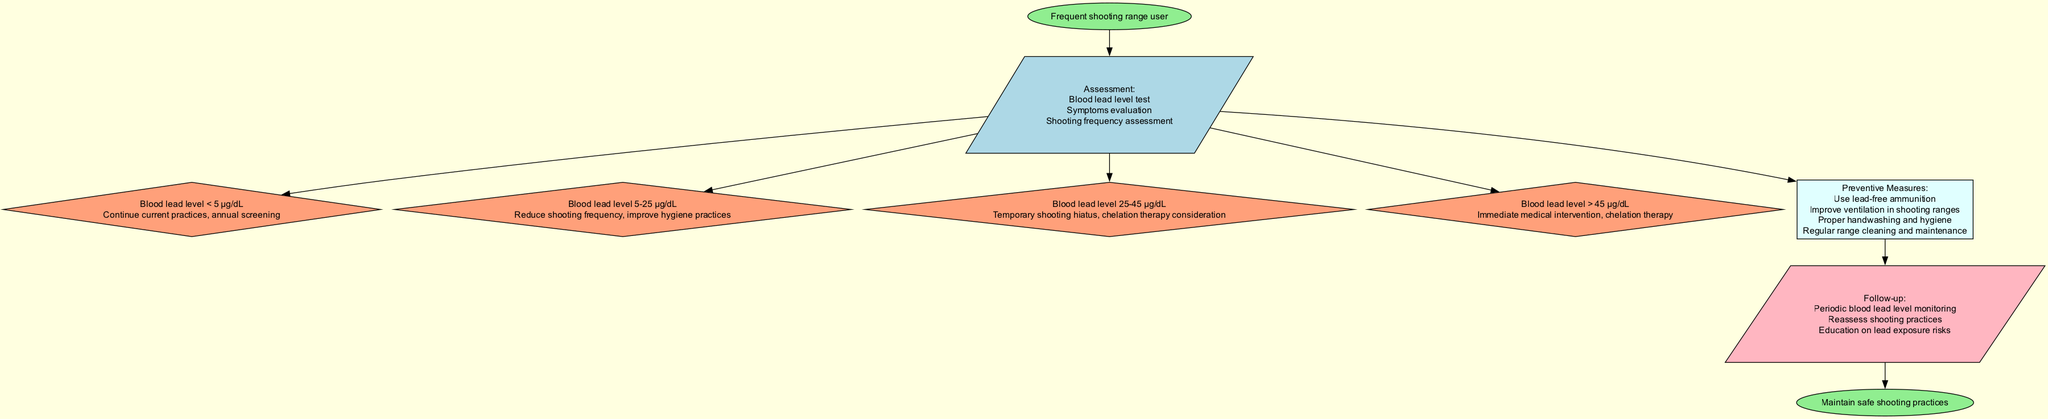What is the starting point of the clinical pathway? The starting point of the clinical pathway is explicitly labeled as "Frequent shooting range user." This signifies that the process begins with this specific group of individuals.
Answer: Frequent shooting range user How many actions are there listed in the diagram? There are four actions in the diagram, each corresponding to a different blood lead level range. They are clearly delineated as distinct nodes branching out from the assessment node.
Answer: 4 What action is recommended for a blood lead level of 5-25 μg/dL? According to the diagram, for a blood lead level of 5-25 μg/dL, the recommended action is to "Reduce shooting frequency, improve hygiene practices." This is specified in the action node for this blood lead level range.
Answer: Reduce shooting frequency, improve hygiene practices What preventive measure is suggested for users? The diagram lists several preventive measures, one of which is "Use lead-free ammunition." This is clearly stated under the preventive measures node and reflects a precaution that can be taken.
Answer: Use lead-free ammunition What does the follow-up section include? The follow-up section includes three instructions: "Periodic blood lead level monitoring," "Reassess shooting practices," and "Education on lead exposure risks." These are outlined under the follow-up node in the diagram.
Answer: Periodic blood lead level monitoring, Reassess shooting practices, Education on lead exposure risks What is the action taken when the blood lead level is above 45 μg/dL? The diagram indicates that for a blood lead level exceeding 45 μg/dL, the action is "Immediate medical intervention, chelation therapy." This is a clear directive for users in this critical range.
Answer: Immediate medical intervention, chelation therapy Which node follows the preventive measures node? The follow-up node directly follows the preventive measures node in the flow of the diagram, indicating the next steps after preventive actions are taken.
Answer: Follow-up What color represents the assessment node in the diagram? The assessment node is filled with light blue color, which is distinctly represented in the diagram to differentiate it visually from other types of nodes.
Answer: Light blue 